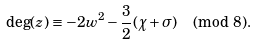Convert formula to latex. <formula><loc_0><loc_0><loc_500><loc_500>\deg ( z ) \equiv - 2 w ^ { 2 } - \frac { 3 } { 2 } ( \chi + \sigma ) \pmod { 8 } .</formula> 